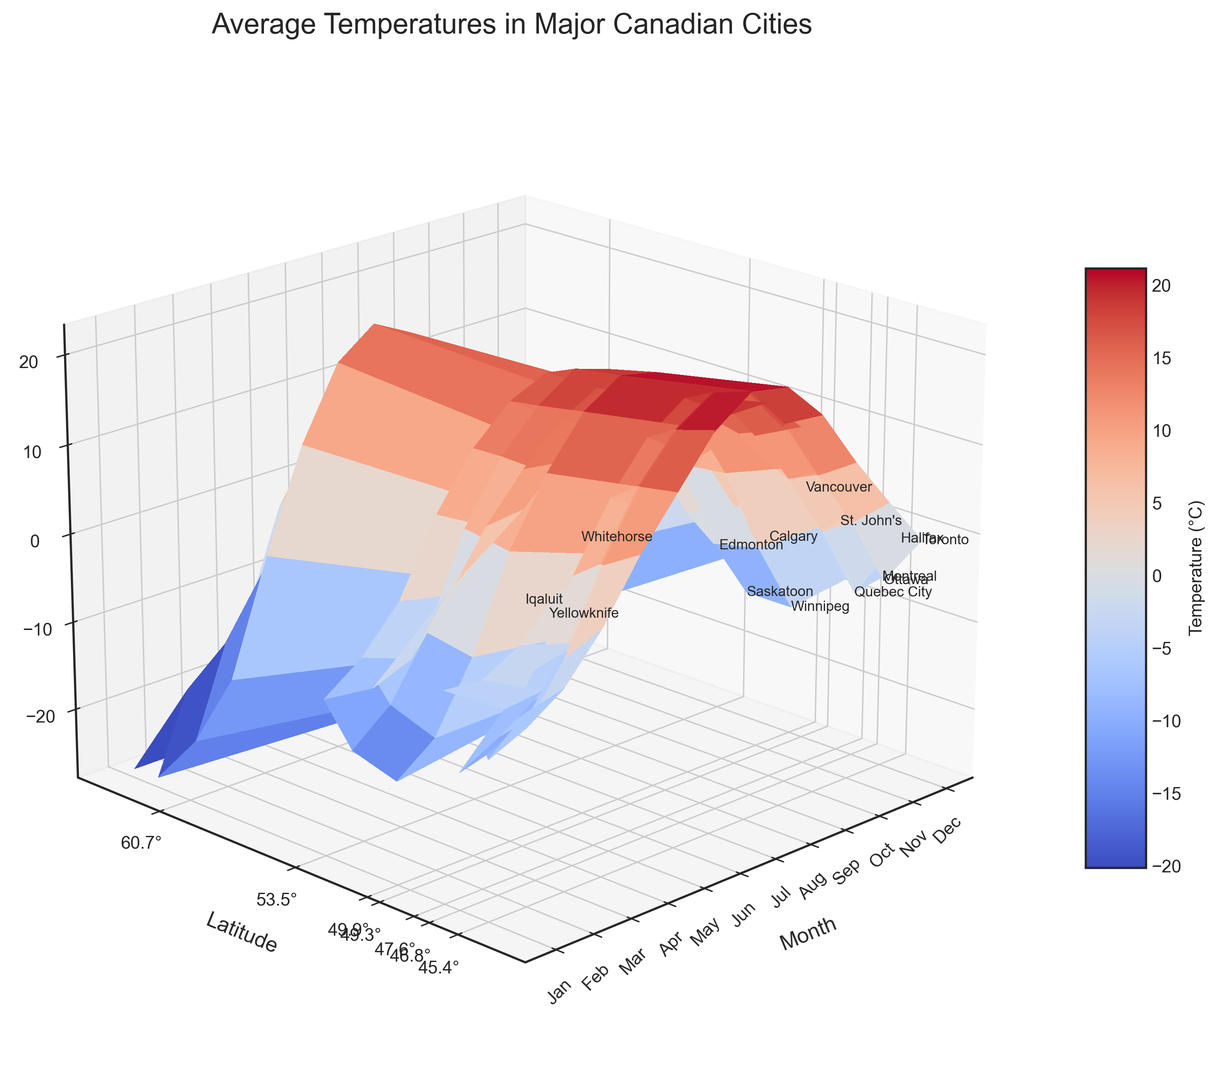Which city experiences the highest average temperature in July? Look at the "July" values across all cities and identify the highest temperature. Vancouver has the highest average temperature in July at 18.3°C.
Answer: Vancouver Which city has the lowest average temperature in January? Look at the "January" values across all cities and identify the lowest temperature. Iqaluit has the lowest average temperature in January at -26.9°C.
Answer: Iqaluit Compare the average temperatures of Toronto and Calgary in April. Which city is warmer? Find the April temperatures for both cities (Toronto: 8.8°C and Calgary: 6.3°C) and compare them. Toronto has a higher average temperature in April than Calgary.
Answer: Toronto What is the average temperature in Ottawa during winter months (Dec, Jan, Feb)? Average the temperatures in Ottawa for December, January, and February. Winter temperatures in Ottawa: Dec (-6.6), Jan (-10.2), Feb (-8.3). Sum: -6.6 + -10.2 + -8.3 = -25.1; Average: -25.1 / 3 ≈ -8.37°C.
Answer: -8.37°C How does the temperature difference between summer (Jul) and winter (Jan) in Whitehorse compare to that in Yellowknife? Calculate the temperature difference for both cities in July and January and compare. Whitehorse: July (15.3°C) - January (-15.2°C) = 30.5°C. Yellowknife: July (17.0°C) - January (-26.8°C) = 43.8°C. Yellowknife has a larger temperature difference than Whitehorse.
Answer: Yellowknife Which city has the smallest temperature range (difference between highest and lowest average temperature)? Calculate the difference between the highest and lowest average temperatures for each city and compare. Vancouver: Max (18.3°C), Min (-0.8°C), Range = 18.3 - (-0.8) = 19.1°C. Vancouver has the smallest temperature range.
Answer: Vancouver In which month does St. John's have the closest average temperature to 0°C? Find the month in St. John's where the temperature is closest to 0°C. March has an average temperature of -2.6°C in St. John's, closest to 0°C.
Answer: March Which city’s temperature curve changes the most dramatically with the season, based on its latitude? By examining the steepness and variability in the temperature curves, identify the city. Iqaluit, with its extreme variation especially in winter and summer months.
Answer: Iqaluit 